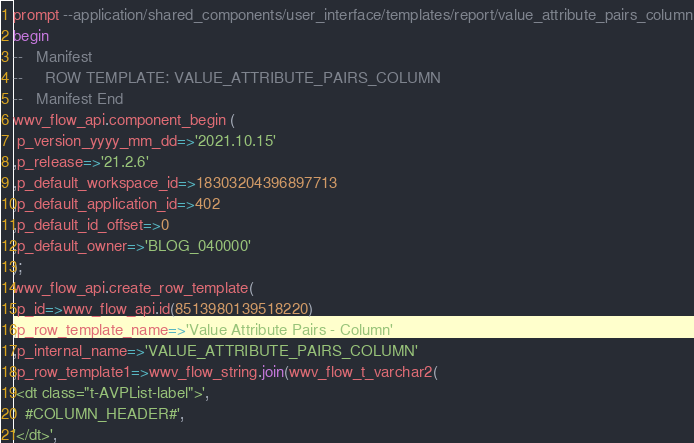Convert code to text. <code><loc_0><loc_0><loc_500><loc_500><_SQL_>prompt --application/shared_components/user_interface/templates/report/value_attribute_pairs_column
begin
--   Manifest
--     ROW TEMPLATE: VALUE_ATTRIBUTE_PAIRS_COLUMN
--   Manifest End
wwv_flow_api.component_begin (
 p_version_yyyy_mm_dd=>'2021.10.15'
,p_release=>'21.2.6'
,p_default_workspace_id=>18303204396897713
,p_default_application_id=>402
,p_default_id_offset=>0
,p_default_owner=>'BLOG_040000'
);
wwv_flow_api.create_row_template(
 p_id=>wwv_flow_api.id(8513980139518220)
,p_row_template_name=>'Value Attribute Pairs - Column'
,p_internal_name=>'VALUE_ATTRIBUTE_PAIRS_COLUMN'
,p_row_template1=>wwv_flow_string.join(wwv_flow_t_varchar2(
'<dt class="t-AVPList-label">',
'  #COLUMN_HEADER#',
'</dt>',</code> 